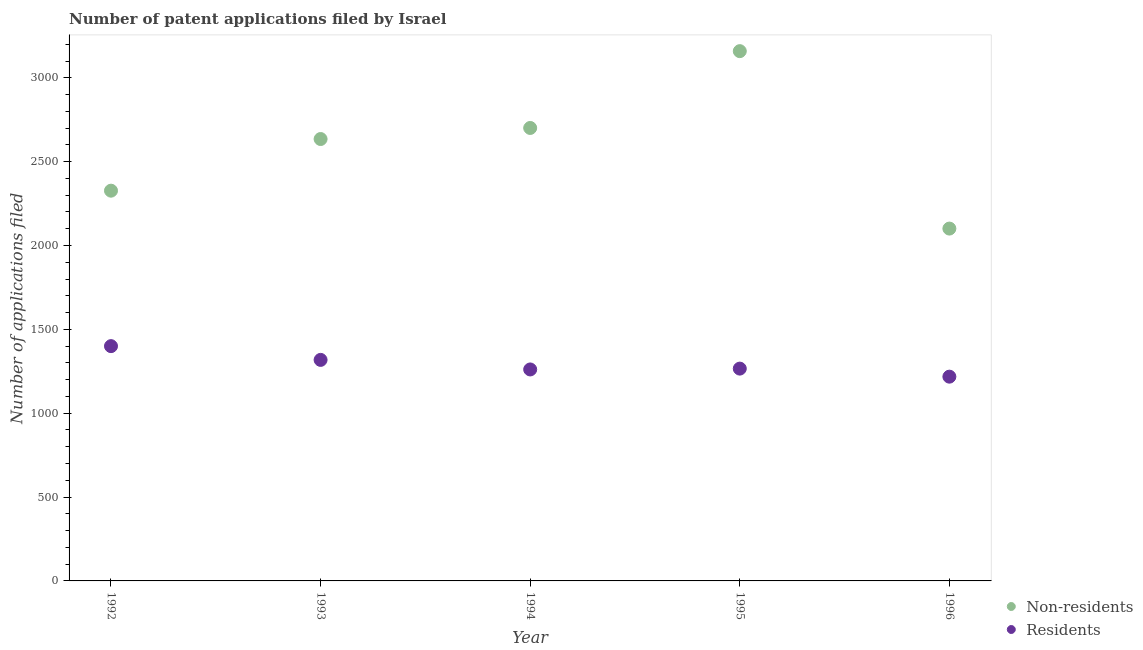How many different coloured dotlines are there?
Ensure brevity in your answer.  2. What is the number of patent applications by residents in 1994?
Your answer should be very brief. 1261. Across all years, what is the maximum number of patent applications by residents?
Give a very brief answer. 1400. Across all years, what is the minimum number of patent applications by residents?
Give a very brief answer. 1218. In which year was the number of patent applications by non residents maximum?
Ensure brevity in your answer.  1995. What is the total number of patent applications by residents in the graph?
Provide a short and direct response. 6463. What is the difference between the number of patent applications by non residents in 1994 and that in 1995?
Keep it short and to the point. -458. What is the difference between the number of patent applications by non residents in 1996 and the number of patent applications by residents in 1992?
Provide a succinct answer. 701. What is the average number of patent applications by residents per year?
Make the answer very short. 1292.6. In the year 1992, what is the difference between the number of patent applications by non residents and number of patent applications by residents?
Provide a short and direct response. 927. In how many years, is the number of patent applications by non residents greater than 2600?
Your answer should be compact. 3. What is the ratio of the number of patent applications by residents in 1993 to that in 1995?
Offer a terse response. 1.04. What is the difference between the highest and the lowest number of patent applications by non residents?
Ensure brevity in your answer.  1058. Is the number of patent applications by residents strictly greater than the number of patent applications by non residents over the years?
Keep it short and to the point. No. Is the number of patent applications by non residents strictly less than the number of patent applications by residents over the years?
Offer a very short reply. No. How many dotlines are there?
Give a very brief answer. 2. How many years are there in the graph?
Offer a terse response. 5. What is the difference between two consecutive major ticks on the Y-axis?
Offer a terse response. 500. Are the values on the major ticks of Y-axis written in scientific E-notation?
Your answer should be very brief. No. Does the graph contain any zero values?
Your response must be concise. No. Does the graph contain grids?
Offer a terse response. No. How are the legend labels stacked?
Give a very brief answer. Vertical. What is the title of the graph?
Keep it short and to the point. Number of patent applications filed by Israel. Does "Personal remittances" appear as one of the legend labels in the graph?
Provide a short and direct response. No. What is the label or title of the X-axis?
Your response must be concise. Year. What is the label or title of the Y-axis?
Give a very brief answer. Number of applications filed. What is the Number of applications filed of Non-residents in 1992?
Make the answer very short. 2327. What is the Number of applications filed in Residents in 1992?
Offer a very short reply. 1400. What is the Number of applications filed in Non-residents in 1993?
Your response must be concise. 2635. What is the Number of applications filed in Residents in 1993?
Ensure brevity in your answer.  1318. What is the Number of applications filed of Non-residents in 1994?
Make the answer very short. 2701. What is the Number of applications filed in Residents in 1994?
Give a very brief answer. 1261. What is the Number of applications filed in Non-residents in 1995?
Provide a short and direct response. 3159. What is the Number of applications filed of Residents in 1995?
Keep it short and to the point. 1266. What is the Number of applications filed of Non-residents in 1996?
Offer a very short reply. 2101. What is the Number of applications filed of Residents in 1996?
Your response must be concise. 1218. Across all years, what is the maximum Number of applications filed of Non-residents?
Keep it short and to the point. 3159. Across all years, what is the maximum Number of applications filed in Residents?
Keep it short and to the point. 1400. Across all years, what is the minimum Number of applications filed of Non-residents?
Offer a terse response. 2101. Across all years, what is the minimum Number of applications filed in Residents?
Offer a terse response. 1218. What is the total Number of applications filed of Non-residents in the graph?
Make the answer very short. 1.29e+04. What is the total Number of applications filed in Residents in the graph?
Provide a short and direct response. 6463. What is the difference between the Number of applications filed in Non-residents in 1992 and that in 1993?
Give a very brief answer. -308. What is the difference between the Number of applications filed of Non-residents in 1992 and that in 1994?
Offer a terse response. -374. What is the difference between the Number of applications filed of Residents in 1992 and that in 1994?
Offer a very short reply. 139. What is the difference between the Number of applications filed in Non-residents in 1992 and that in 1995?
Make the answer very short. -832. What is the difference between the Number of applications filed in Residents in 1992 and that in 1995?
Ensure brevity in your answer.  134. What is the difference between the Number of applications filed in Non-residents in 1992 and that in 1996?
Your response must be concise. 226. What is the difference between the Number of applications filed of Residents in 1992 and that in 1996?
Your response must be concise. 182. What is the difference between the Number of applications filed of Non-residents in 1993 and that in 1994?
Provide a succinct answer. -66. What is the difference between the Number of applications filed in Residents in 1993 and that in 1994?
Give a very brief answer. 57. What is the difference between the Number of applications filed in Non-residents in 1993 and that in 1995?
Your response must be concise. -524. What is the difference between the Number of applications filed in Residents in 1993 and that in 1995?
Your response must be concise. 52. What is the difference between the Number of applications filed of Non-residents in 1993 and that in 1996?
Make the answer very short. 534. What is the difference between the Number of applications filed in Residents in 1993 and that in 1996?
Your answer should be very brief. 100. What is the difference between the Number of applications filed in Non-residents in 1994 and that in 1995?
Offer a very short reply. -458. What is the difference between the Number of applications filed in Residents in 1994 and that in 1995?
Your response must be concise. -5. What is the difference between the Number of applications filed of Non-residents in 1994 and that in 1996?
Ensure brevity in your answer.  600. What is the difference between the Number of applications filed in Non-residents in 1995 and that in 1996?
Provide a succinct answer. 1058. What is the difference between the Number of applications filed in Residents in 1995 and that in 1996?
Make the answer very short. 48. What is the difference between the Number of applications filed in Non-residents in 1992 and the Number of applications filed in Residents in 1993?
Give a very brief answer. 1009. What is the difference between the Number of applications filed in Non-residents in 1992 and the Number of applications filed in Residents in 1994?
Provide a succinct answer. 1066. What is the difference between the Number of applications filed in Non-residents in 1992 and the Number of applications filed in Residents in 1995?
Your response must be concise. 1061. What is the difference between the Number of applications filed in Non-residents in 1992 and the Number of applications filed in Residents in 1996?
Offer a very short reply. 1109. What is the difference between the Number of applications filed of Non-residents in 1993 and the Number of applications filed of Residents in 1994?
Your answer should be compact. 1374. What is the difference between the Number of applications filed of Non-residents in 1993 and the Number of applications filed of Residents in 1995?
Your response must be concise. 1369. What is the difference between the Number of applications filed of Non-residents in 1993 and the Number of applications filed of Residents in 1996?
Offer a very short reply. 1417. What is the difference between the Number of applications filed of Non-residents in 1994 and the Number of applications filed of Residents in 1995?
Your answer should be compact. 1435. What is the difference between the Number of applications filed of Non-residents in 1994 and the Number of applications filed of Residents in 1996?
Your answer should be very brief. 1483. What is the difference between the Number of applications filed in Non-residents in 1995 and the Number of applications filed in Residents in 1996?
Ensure brevity in your answer.  1941. What is the average Number of applications filed in Non-residents per year?
Give a very brief answer. 2584.6. What is the average Number of applications filed of Residents per year?
Offer a very short reply. 1292.6. In the year 1992, what is the difference between the Number of applications filed in Non-residents and Number of applications filed in Residents?
Offer a very short reply. 927. In the year 1993, what is the difference between the Number of applications filed of Non-residents and Number of applications filed of Residents?
Provide a short and direct response. 1317. In the year 1994, what is the difference between the Number of applications filed of Non-residents and Number of applications filed of Residents?
Provide a short and direct response. 1440. In the year 1995, what is the difference between the Number of applications filed in Non-residents and Number of applications filed in Residents?
Keep it short and to the point. 1893. In the year 1996, what is the difference between the Number of applications filed of Non-residents and Number of applications filed of Residents?
Your answer should be very brief. 883. What is the ratio of the Number of applications filed in Non-residents in 1992 to that in 1993?
Make the answer very short. 0.88. What is the ratio of the Number of applications filed of Residents in 1992 to that in 1993?
Keep it short and to the point. 1.06. What is the ratio of the Number of applications filed of Non-residents in 1992 to that in 1994?
Ensure brevity in your answer.  0.86. What is the ratio of the Number of applications filed in Residents in 1992 to that in 1994?
Your response must be concise. 1.11. What is the ratio of the Number of applications filed of Non-residents in 1992 to that in 1995?
Provide a succinct answer. 0.74. What is the ratio of the Number of applications filed in Residents in 1992 to that in 1995?
Your answer should be compact. 1.11. What is the ratio of the Number of applications filed in Non-residents in 1992 to that in 1996?
Keep it short and to the point. 1.11. What is the ratio of the Number of applications filed of Residents in 1992 to that in 1996?
Offer a very short reply. 1.15. What is the ratio of the Number of applications filed of Non-residents in 1993 to that in 1994?
Give a very brief answer. 0.98. What is the ratio of the Number of applications filed of Residents in 1993 to that in 1994?
Offer a very short reply. 1.05. What is the ratio of the Number of applications filed in Non-residents in 1993 to that in 1995?
Keep it short and to the point. 0.83. What is the ratio of the Number of applications filed in Residents in 1993 to that in 1995?
Your answer should be compact. 1.04. What is the ratio of the Number of applications filed of Non-residents in 1993 to that in 1996?
Offer a terse response. 1.25. What is the ratio of the Number of applications filed in Residents in 1993 to that in 1996?
Provide a short and direct response. 1.08. What is the ratio of the Number of applications filed in Non-residents in 1994 to that in 1995?
Offer a very short reply. 0.85. What is the ratio of the Number of applications filed in Residents in 1994 to that in 1995?
Offer a very short reply. 1. What is the ratio of the Number of applications filed in Non-residents in 1994 to that in 1996?
Give a very brief answer. 1.29. What is the ratio of the Number of applications filed in Residents in 1994 to that in 1996?
Offer a very short reply. 1.04. What is the ratio of the Number of applications filed in Non-residents in 1995 to that in 1996?
Ensure brevity in your answer.  1.5. What is the ratio of the Number of applications filed of Residents in 1995 to that in 1996?
Ensure brevity in your answer.  1.04. What is the difference between the highest and the second highest Number of applications filed in Non-residents?
Your answer should be very brief. 458. What is the difference between the highest and the second highest Number of applications filed in Residents?
Make the answer very short. 82. What is the difference between the highest and the lowest Number of applications filed of Non-residents?
Offer a very short reply. 1058. What is the difference between the highest and the lowest Number of applications filed of Residents?
Your answer should be very brief. 182. 